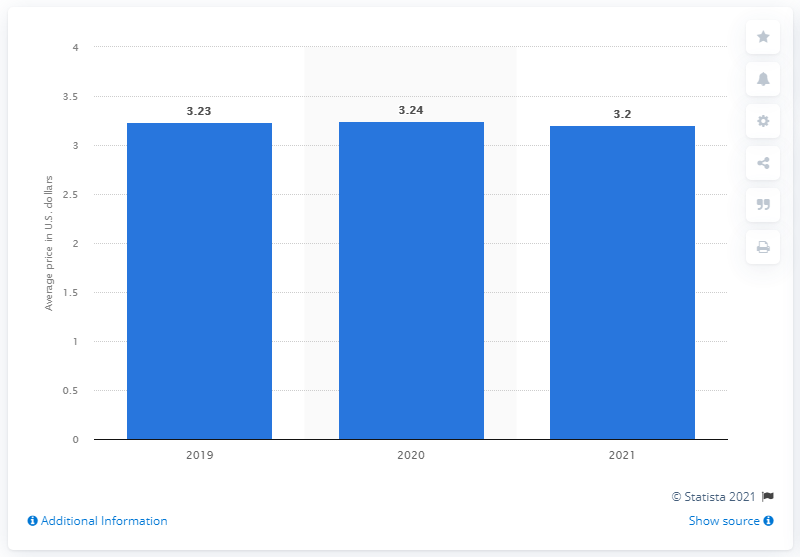Point out several critical features in this image. In 2021, the average cost of a Big Mac in the United States was estimated to be 3.2 U.S. dollars. In 2021, the average cost of a Big Mac in Guatemala was 3.2 dollars. 